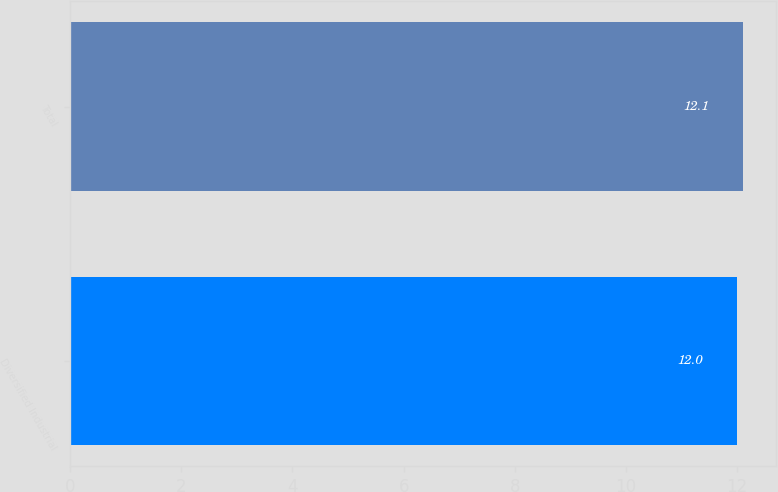Convert chart to OTSL. <chart><loc_0><loc_0><loc_500><loc_500><bar_chart><fcel>Diversified Industrial<fcel>Total<nl><fcel>12<fcel>12.1<nl></chart> 